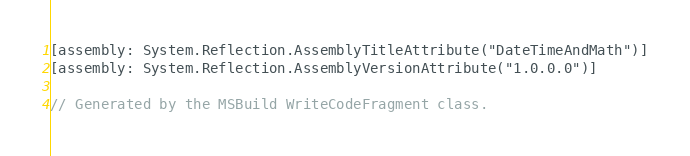<code> <loc_0><loc_0><loc_500><loc_500><_C#_>[assembly: System.Reflection.AssemblyTitleAttribute("DateTimeAndMath")]
[assembly: System.Reflection.AssemblyVersionAttribute("1.0.0.0")]

// Generated by the MSBuild WriteCodeFragment class.

</code> 